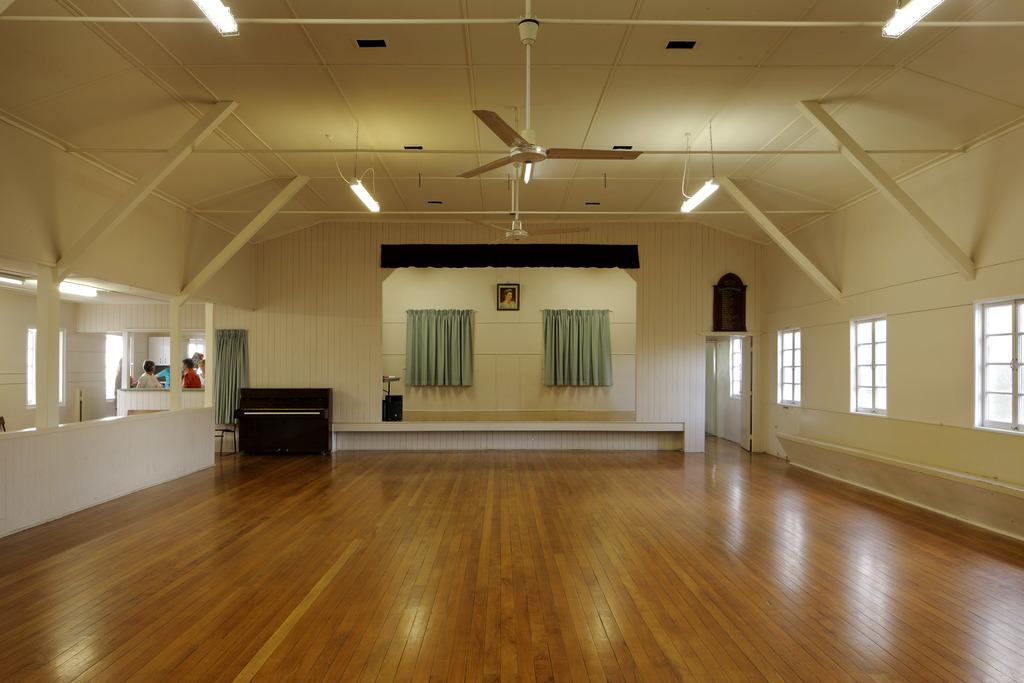What can be seen in the left corner of the image? There are people standing in the left corner of the image. How many curtains are present in the image? There are two curtains in the image. What type of appliances can be seen in the image? There are fans visible in the image. What type of lighting is present in the image? There are lights in the image. What is the color of the floor in the image? The floor is brown in color. Can you tell me how many campers are visible in the image? There is no mention of campers or a camp in the image; it features people, curtains, fans, lights, and a brown floor. What type of pocket can be seen on the edge of the image? There is no pocket visible in the image; it only contains people, curtains, fans, lights, and a brown floor. 